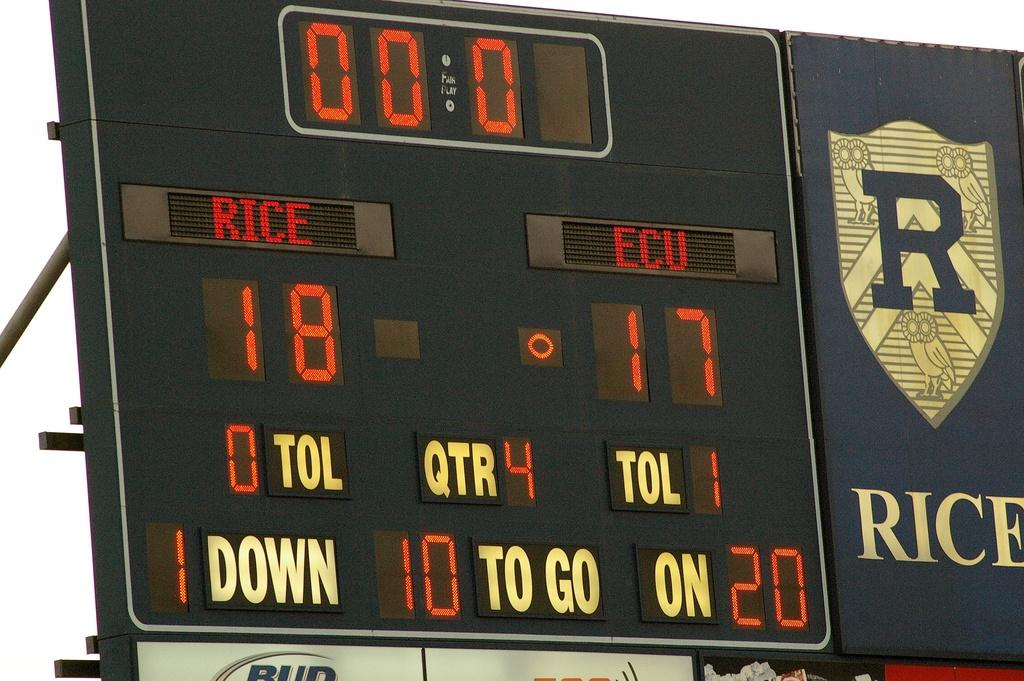<image>
Share a concise interpretation of the image provided. The scoreboard of a football game shoes that Rice is winning. 